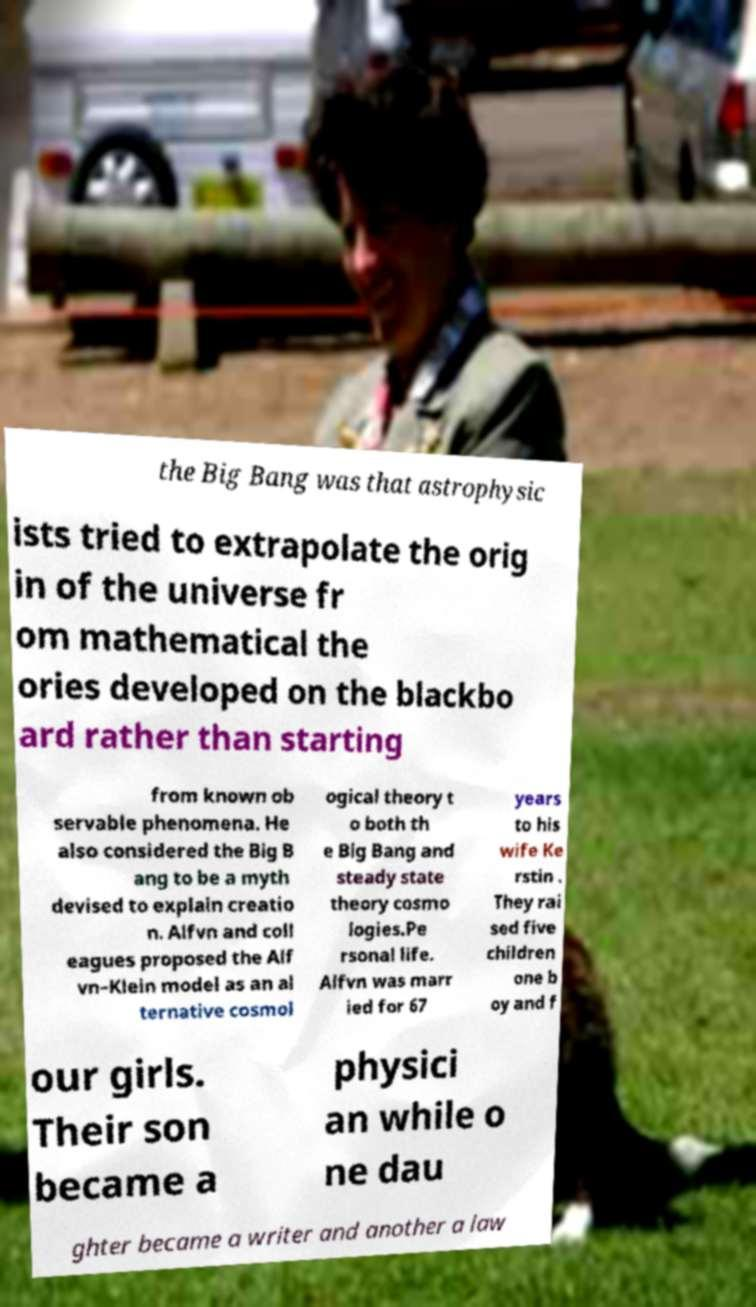Please read and relay the text visible in this image. What does it say? the Big Bang was that astrophysic ists tried to extrapolate the orig in of the universe fr om mathematical the ories developed on the blackbo ard rather than starting from known ob servable phenomena. He also considered the Big B ang to be a myth devised to explain creatio n. Alfvn and coll eagues proposed the Alf vn–Klein model as an al ternative cosmol ogical theory t o both th e Big Bang and steady state theory cosmo logies.Pe rsonal life. Alfvn was marr ied for 67 years to his wife Ke rstin . They rai sed five children one b oy and f our girls. Their son became a physici an while o ne dau ghter became a writer and another a law 